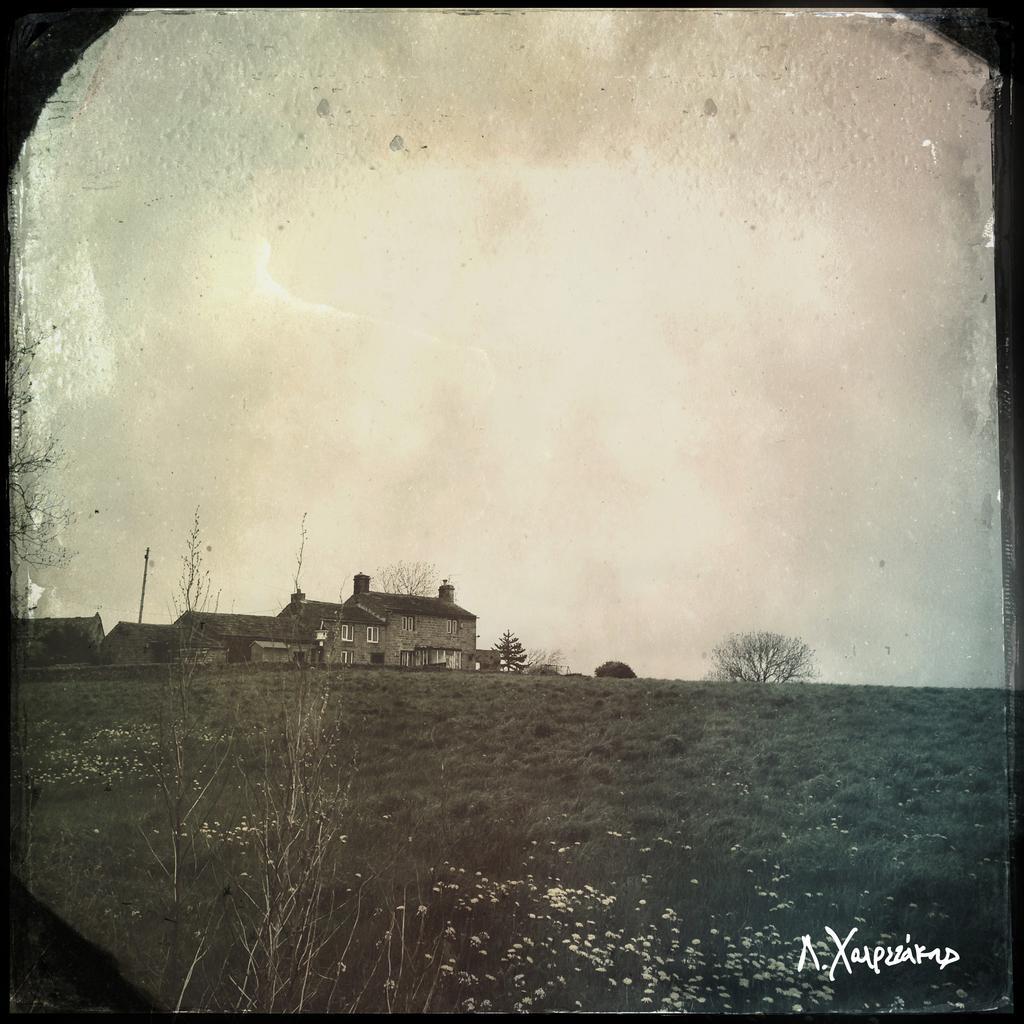How would you summarize this image in a sentence or two? This is a black and white picture. At the bottom of the picture, we see the plants and the grass. There are trees and buildings in the background. We see a pole. At the top of the picture, we see the sky. This picture might be a photo frame. 